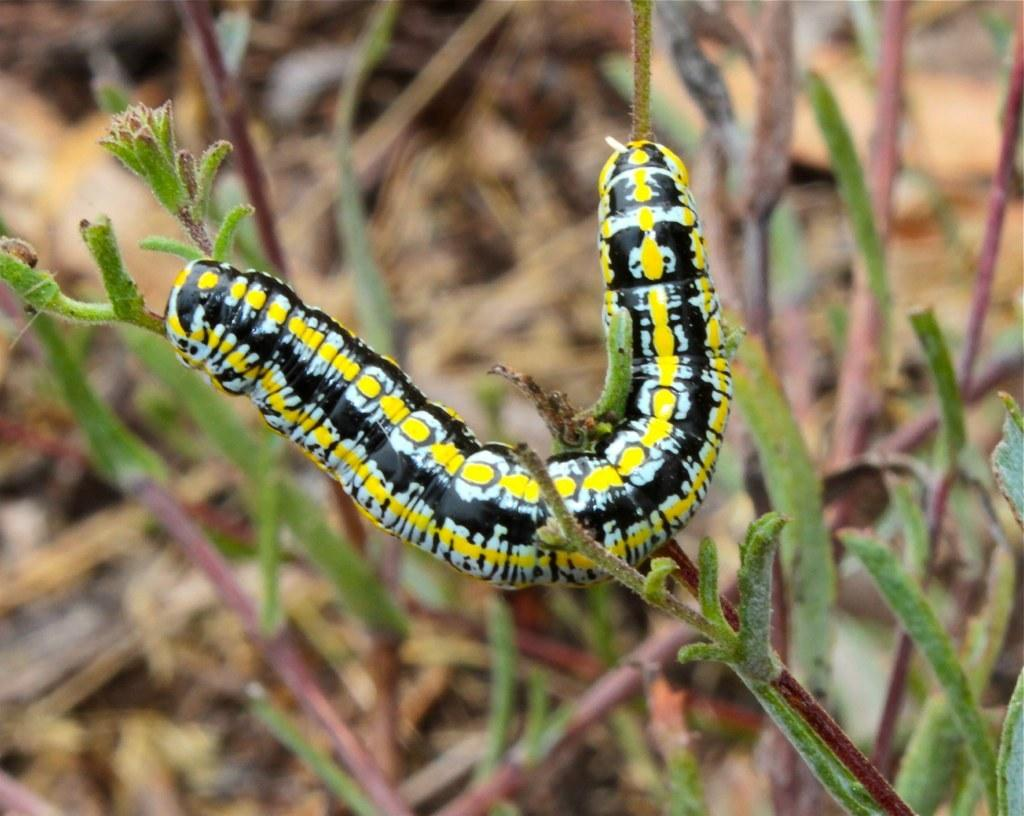What is the main subject of the image? There is a caterpillar in the image. Can you describe the colors of the caterpillar? The caterpillar has yellow, white, and black colors. Where is the caterpillar located? The caterpillar is on a plant. What colors are present in the background of the image? The background of the image is brown and green. What direction is the caterpillar facing in the image? The direction the caterpillar is facing cannot be determined from the image, as caterpillars do not have a distinguishable front or back. 